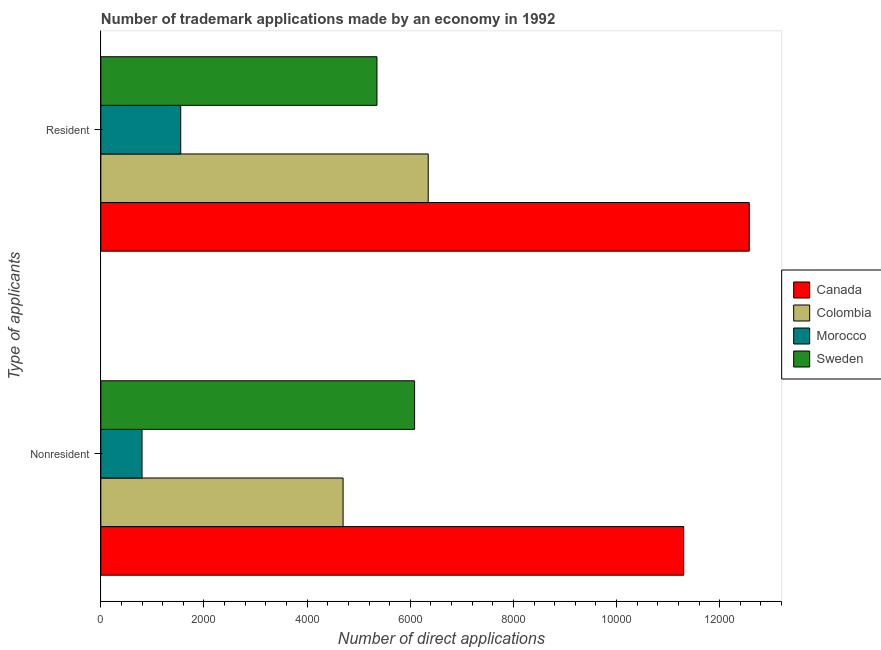Are the number of bars per tick equal to the number of legend labels?
Provide a short and direct response. Yes. Are the number of bars on each tick of the Y-axis equal?
Give a very brief answer. Yes. What is the label of the 2nd group of bars from the top?
Your answer should be very brief. Nonresident. What is the number of trademark applications made by non residents in Sweden?
Your answer should be compact. 6084. Across all countries, what is the maximum number of trademark applications made by residents?
Offer a very short reply. 1.26e+04. Across all countries, what is the minimum number of trademark applications made by residents?
Ensure brevity in your answer.  1549. In which country was the number of trademark applications made by non residents maximum?
Keep it short and to the point. Canada. In which country was the number of trademark applications made by residents minimum?
Provide a succinct answer. Morocco. What is the total number of trademark applications made by residents in the graph?
Give a very brief answer. 2.58e+04. What is the difference between the number of trademark applications made by residents in Sweden and that in Canada?
Provide a short and direct response. -7219. What is the difference between the number of trademark applications made by residents in Sweden and the number of trademark applications made by non residents in Morocco?
Give a very brief answer. 4555. What is the average number of trademark applications made by non residents per country?
Keep it short and to the point. 5720.5. What is the difference between the number of trademark applications made by residents and number of trademark applications made by non residents in Morocco?
Make the answer very short. 750. What is the ratio of the number of trademark applications made by residents in Canada to that in Morocco?
Make the answer very short. 8.12. What does the 3rd bar from the bottom in Resident represents?
Offer a terse response. Morocco. How many bars are there?
Your answer should be very brief. 8. Are all the bars in the graph horizontal?
Keep it short and to the point. Yes. How many countries are there in the graph?
Provide a short and direct response. 4. What is the difference between two consecutive major ticks on the X-axis?
Offer a terse response. 2000. Are the values on the major ticks of X-axis written in scientific E-notation?
Provide a short and direct response. No. Does the graph contain grids?
Your answer should be compact. No. Where does the legend appear in the graph?
Offer a terse response. Center right. How are the legend labels stacked?
Offer a very short reply. Vertical. What is the title of the graph?
Your answer should be very brief. Number of trademark applications made by an economy in 1992. What is the label or title of the X-axis?
Your answer should be very brief. Number of direct applications. What is the label or title of the Y-axis?
Offer a terse response. Type of applicants. What is the Number of direct applications of Canada in Nonresident?
Offer a terse response. 1.13e+04. What is the Number of direct applications in Colombia in Nonresident?
Offer a terse response. 4697. What is the Number of direct applications in Morocco in Nonresident?
Give a very brief answer. 799. What is the Number of direct applications in Sweden in Nonresident?
Provide a succinct answer. 6084. What is the Number of direct applications in Canada in Resident?
Provide a succinct answer. 1.26e+04. What is the Number of direct applications of Colombia in Resident?
Offer a terse response. 6348. What is the Number of direct applications in Morocco in Resident?
Offer a very short reply. 1549. What is the Number of direct applications of Sweden in Resident?
Provide a short and direct response. 5354. Across all Type of applicants, what is the maximum Number of direct applications in Canada?
Keep it short and to the point. 1.26e+04. Across all Type of applicants, what is the maximum Number of direct applications in Colombia?
Your answer should be compact. 6348. Across all Type of applicants, what is the maximum Number of direct applications of Morocco?
Provide a succinct answer. 1549. Across all Type of applicants, what is the maximum Number of direct applications of Sweden?
Keep it short and to the point. 6084. Across all Type of applicants, what is the minimum Number of direct applications of Canada?
Your answer should be very brief. 1.13e+04. Across all Type of applicants, what is the minimum Number of direct applications in Colombia?
Offer a very short reply. 4697. Across all Type of applicants, what is the minimum Number of direct applications of Morocco?
Your answer should be compact. 799. Across all Type of applicants, what is the minimum Number of direct applications in Sweden?
Ensure brevity in your answer.  5354. What is the total Number of direct applications of Canada in the graph?
Offer a terse response. 2.39e+04. What is the total Number of direct applications in Colombia in the graph?
Keep it short and to the point. 1.10e+04. What is the total Number of direct applications in Morocco in the graph?
Give a very brief answer. 2348. What is the total Number of direct applications of Sweden in the graph?
Give a very brief answer. 1.14e+04. What is the difference between the Number of direct applications in Canada in Nonresident and that in Resident?
Give a very brief answer. -1271. What is the difference between the Number of direct applications in Colombia in Nonresident and that in Resident?
Your answer should be compact. -1651. What is the difference between the Number of direct applications of Morocco in Nonresident and that in Resident?
Your answer should be very brief. -750. What is the difference between the Number of direct applications of Sweden in Nonresident and that in Resident?
Provide a succinct answer. 730. What is the difference between the Number of direct applications of Canada in Nonresident and the Number of direct applications of Colombia in Resident?
Provide a short and direct response. 4954. What is the difference between the Number of direct applications in Canada in Nonresident and the Number of direct applications in Morocco in Resident?
Provide a short and direct response. 9753. What is the difference between the Number of direct applications of Canada in Nonresident and the Number of direct applications of Sweden in Resident?
Your answer should be compact. 5948. What is the difference between the Number of direct applications in Colombia in Nonresident and the Number of direct applications in Morocco in Resident?
Your answer should be very brief. 3148. What is the difference between the Number of direct applications of Colombia in Nonresident and the Number of direct applications of Sweden in Resident?
Your answer should be compact. -657. What is the difference between the Number of direct applications in Morocco in Nonresident and the Number of direct applications in Sweden in Resident?
Ensure brevity in your answer.  -4555. What is the average Number of direct applications of Canada per Type of applicants?
Your answer should be very brief. 1.19e+04. What is the average Number of direct applications of Colombia per Type of applicants?
Your answer should be very brief. 5522.5. What is the average Number of direct applications in Morocco per Type of applicants?
Your answer should be compact. 1174. What is the average Number of direct applications of Sweden per Type of applicants?
Offer a terse response. 5719. What is the difference between the Number of direct applications in Canada and Number of direct applications in Colombia in Nonresident?
Your answer should be compact. 6605. What is the difference between the Number of direct applications of Canada and Number of direct applications of Morocco in Nonresident?
Offer a very short reply. 1.05e+04. What is the difference between the Number of direct applications in Canada and Number of direct applications in Sweden in Nonresident?
Offer a terse response. 5218. What is the difference between the Number of direct applications in Colombia and Number of direct applications in Morocco in Nonresident?
Give a very brief answer. 3898. What is the difference between the Number of direct applications of Colombia and Number of direct applications of Sweden in Nonresident?
Ensure brevity in your answer.  -1387. What is the difference between the Number of direct applications of Morocco and Number of direct applications of Sweden in Nonresident?
Make the answer very short. -5285. What is the difference between the Number of direct applications of Canada and Number of direct applications of Colombia in Resident?
Offer a terse response. 6225. What is the difference between the Number of direct applications in Canada and Number of direct applications in Morocco in Resident?
Provide a succinct answer. 1.10e+04. What is the difference between the Number of direct applications of Canada and Number of direct applications of Sweden in Resident?
Your answer should be very brief. 7219. What is the difference between the Number of direct applications in Colombia and Number of direct applications in Morocco in Resident?
Provide a succinct answer. 4799. What is the difference between the Number of direct applications in Colombia and Number of direct applications in Sweden in Resident?
Ensure brevity in your answer.  994. What is the difference between the Number of direct applications of Morocco and Number of direct applications of Sweden in Resident?
Ensure brevity in your answer.  -3805. What is the ratio of the Number of direct applications in Canada in Nonresident to that in Resident?
Offer a terse response. 0.9. What is the ratio of the Number of direct applications of Colombia in Nonresident to that in Resident?
Keep it short and to the point. 0.74. What is the ratio of the Number of direct applications in Morocco in Nonresident to that in Resident?
Provide a succinct answer. 0.52. What is the ratio of the Number of direct applications in Sweden in Nonresident to that in Resident?
Keep it short and to the point. 1.14. What is the difference between the highest and the second highest Number of direct applications in Canada?
Offer a terse response. 1271. What is the difference between the highest and the second highest Number of direct applications in Colombia?
Offer a very short reply. 1651. What is the difference between the highest and the second highest Number of direct applications of Morocco?
Give a very brief answer. 750. What is the difference between the highest and the second highest Number of direct applications of Sweden?
Keep it short and to the point. 730. What is the difference between the highest and the lowest Number of direct applications in Canada?
Your response must be concise. 1271. What is the difference between the highest and the lowest Number of direct applications in Colombia?
Keep it short and to the point. 1651. What is the difference between the highest and the lowest Number of direct applications in Morocco?
Offer a terse response. 750. What is the difference between the highest and the lowest Number of direct applications of Sweden?
Give a very brief answer. 730. 